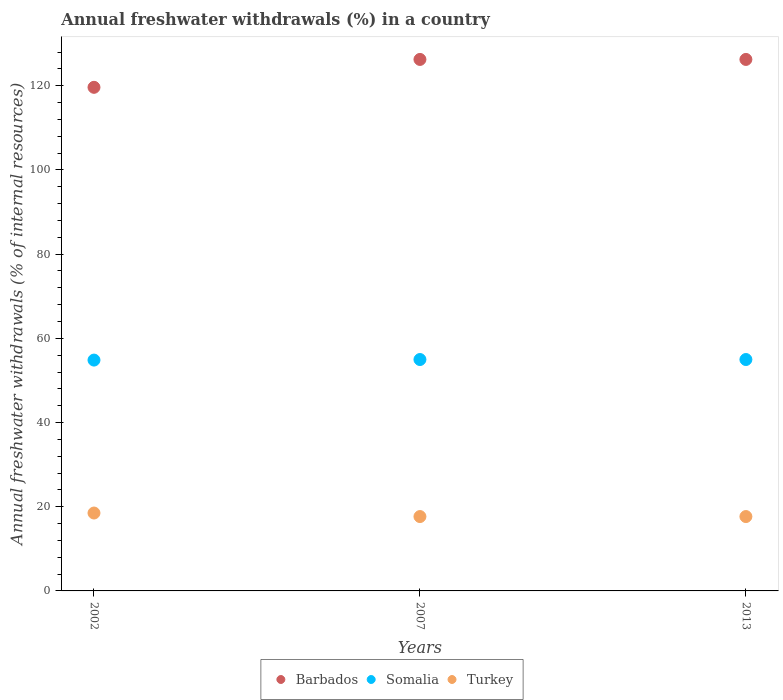How many different coloured dotlines are there?
Provide a short and direct response. 3. What is the percentage of annual freshwater withdrawals in Somalia in 2002?
Your response must be concise. 54.83. Across all years, what is the maximum percentage of annual freshwater withdrawals in Turkey?
Provide a succinct answer. 18.5. Across all years, what is the minimum percentage of annual freshwater withdrawals in Somalia?
Offer a terse response. 54.83. In which year was the percentage of annual freshwater withdrawals in Barbados maximum?
Your response must be concise. 2007. What is the total percentage of annual freshwater withdrawals in Barbados in the graph?
Provide a short and direct response. 372.12. What is the difference between the percentage of annual freshwater withdrawals in Barbados in 2002 and that in 2013?
Offer a very short reply. -6.62. What is the difference between the percentage of annual freshwater withdrawals in Barbados in 2002 and the percentage of annual freshwater withdrawals in Somalia in 2013?
Offer a terse response. 64.66. What is the average percentage of annual freshwater withdrawals in Turkey per year?
Give a very brief answer. 17.94. In the year 2007, what is the difference between the percentage of annual freshwater withdrawals in Turkey and percentage of annual freshwater withdrawals in Somalia?
Offer a very short reply. -37.3. In how many years, is the percentage of annual freshwater withdrawals in Somalia greater than 72 %?
Offer a very short reply. 0. What is the ratio of the percentage of annual freshwater withdrawals in Barbados in 2002 to that in 2007?
Make the answer very short. 0.95. Is the percentage of annual freshwater withdrawals in Barbados in 2007 less than that in 2013?
Keep it short and to the point. No. What is the difference between the highest and the second highest percentage of annual freshwater withdrawals in Somalia?
Your answer should be compact. 0. What is the difference between the highest and the lowest percentage of annual freshwater withdrawals in Barbados?
Offer a very short reply. 6.62. In how many years, is the percentage of annual freshwater withdrawals in Turkey greater than the average percentage of annual freshwater withdrawals in Turkey taken over all years?
Ensure brevity in your answer.  1. Is the sum of the percentage of annual freshwater withdrawals in Barbados in 2002 and 2013 greater than the maximum percentage of annual freshwater withdrawals in Somalia across all years?
Make the answer very short. Yes. Is it the case that in every year, the sum of the percentage of annual freshwater withdrawals in Turkey and percentage of annual freshwater withdrawals in Barbados  is greater than the percentage of annual freshwater withdrawals in Somalia?
Your response must be concise. Yes. Is the percentage of annual freshwater withdrawals in Barbados strictly greater than the percentage of annual freshwater withdrawals in Turkey over the years?
Provide a succinct answer. Yes. Is the percentage of annual freshwater withdrawals in Barbados strictly less than the percentage of annual freshwater withdrawals in Turkey over the years?
Provide a succinct answer. No. How many dotlines are there?
Make the answer very short. 3. What is the difference between two consecutive major ticks on the Y-axis?
Give a very brief answer. 20. Does the graph contain grids?
Offer a terse response. No. What is the title of the graph?
Offer a very short reply. Annual freshwater withdrawals (%) in a country. What is the label or title of the X-axis?
Provide a succinct answer. Years. What is the label or title of the Y-axis?
Ensure brevity in your answer.  Annual freshwater withdrawals (% of internal resources). What is the Annual freshwater withdrawals (% of internal resources) of Barbados in 2002?
Provide a short and direct response. 119.62. What is the Annual freshwater withdrawals (% of internal resources) in Somalia in 2002?
Provide a succinct answer. 54.83. What is the Annual freshwater withdrawals (% of internal resources) in Turkey in 2002?
Keep it short and to the point. 18.5. What is the Annual freshwater withdrawals (% of internal resources) in Barbados in 2007?
Offer a terse response. 126.25. What is the Annual freshwater withdrawals (% of internal resources) in Somalia in 2007?
Offer a very short reply. 54.97. What is the Annual freshwater withdrawals (% of internal resources) in Turkey in 2007?
Provide a short and direct response. 17.67. What is the Annual freshwater withdrawals (% of internal resources) of Barbados in 2013?
Your answer should be compact. 126.25. What is the Annual freshwater withdrawals (% of internal resources) in Somalia in 2013?
Provide a short and direct response. 54.97. What is the Annual freshwater withdrawals (% of internal resources) in Turkey in 2013?
Your answer should be compact. 17.67. Across all years, what is the maximum Annual freshwater withdrawals (% of internal resources) of Barbados?
Your response must be concise. 126.25. Across all years, what is the maximum Annual freshwater withdrawals (% of internal resources) in Somalia?
Offer a terse response. 54.97. Across all years, what is the maximum Annual freshwater withdrawals (% of internal resources) of Turkey?
Ensure brevity in your answer.  18.5. Across all years, what is the minimum Annual freshwater withdrawals (% of internal resources) in Barbados?
Offer a very short reply. 119.62. Across all years, what is the minimum Annual freshwater withdrawals (% of internal resources) in Somalia?
Ensure brevity in your answer.  54.83. Across all years, what is the minimum Annual freshwater withdrawals (% of internal resources) of Turkey?
Ensure brevity in your answer.  17.67. What is the total Annual freshwater withdrawals (% of internal resources) in Barbados in the graph?
Give a very brief answer. 372.12. What is the total Annual freshwater withdrawals (% of internal resources) of Somalia in the graph?
Make the answer very short. 164.77. What is the total Annual freshwater withdrawals (% of internal resources) in Turkey in the graph?
Offer a very short reply. 53.83. What is the difference between the Annual freshwater withdrawals (% of internal resources) in Barbados in 2002 and that in 2007?
Offer a very short reply. -6.62. What is the difference between the Annual freshwater withdrawals (% of internal resources) in Somalia in 2002 and that in 2007?
Provide a short and direct response. -0.13. What is the difference between the Annual freshwater withdrawals (% of internal resources) in Turkey in 2002 and that in 2007?
Offer a terse response. 0.84. What is the difference between the Annual freshwater withdrawals (% of internal resources) in Barbados in 2002 and that in 2013?
Ensure brevity in your answer.  -6.62. What is the difference between the Annual freshwater withdrawals (% of internal resources) in Somalia in 2002 and that in 2013?
Keep it short and to the point. -0.13. What is the difference between the Annual freshwater withdrawals (% of internal resources) of Turkey in 2002 and that in 2013?
Offer a very short reply. 0.84. What is the difference between the Annual freshwater withdrawals (% of internal resources) in Barbados in 2007 and that in 2013?
Provide a short and direct response. 0. What is the difference between the Annual freshwater withdrawals (% of internal resources) of Turkey in 2007 and that in 2013?
Your answer should be very brief. 0. What is the difference between the Annual freshwater withdrawals (% of internal resources) of Barbados in 2002 and the Annual freshwater withdrawals (% of internal resources) of Somalia in 2007?
Keep it short and to the point. 64.66. What is the difference between the Annual freshwater withdrawals (% of internal resources) in Barbados in 2002 and the Annual freshwater withdrawals (% of internal resources) in Turkey in 2007?
Make the answer very short. 101.96. What is the difference between the Annual freshwater withdrawals (% of internal resources) of Somalia in 2002 and the Annual freshwater withdrawals (% of internal resources) of Turkey in 2007?
Make the answer very short. 37.17. What is the difference between the Annual freshwater withdrawals (% of internal resources) of Barbados in 2002 and the Annual freshwater withdrawals (% of internal resources) of Somalia in 2013?
Offer a terse response. 64.66. What is the difference between the Annual freshwater withdrawals (% of internal resources) of Barbados in 2002 and the Annual freshwater withdrawals (% of internal resources) of Turkey in 2013?
Ensure brevity in your answer.  101.96. What is the difference between the Annual freshwater withdrawals (% of internal resources) of Somalia in 2002 and the Annual freshwater withdrawals (% of internal resources) of Turkey in 2013?
Offer a very short reply. 37.17. What is the difference between the Annual freshwater withdrawals (% of internal resources) of Barbados in 2007 and the Annual freshwater withdrawals (% of internal resources) of Somalia in 2013?
Offer a terse response. 71.28. What is the difference between the Annual freshwater withdrawals (% of internal resources) of Barbados in 2007 and the Annual freshwater withdrawals (% of internal resources) of Turkey in 2013?
Offer a terse response. 108.58. What is the difference between the Annual freshwater withdrawals (% of internal resources) in Somalia in 2007 and the Annual freshwater withdrawals (% of internal resources) in Turkey in 2013?
Give a very brief answer. 37.3. What is the average Annual freshwater withdrawals (% of internal resources) in Barbados per year?
Keep it short and to the point. 124.04. What is the average Annual freshwater withdrawals (% of internal resources) in Somalia per year?
Offer a very short reply. 54.92. What is the average Annual freshwater withdrawals (% of internal resources) in Turkey per year?
Your response must be concise. 17.94. In the year 2002, what is the difference between the Annual freshwater withdrawals (% of internal resources) of Barbados and Annual freshwater withdrawals (% of internal resources) of Somalia?
Make the answer very short. 64.79. In the year 2002, what is the difference between the Annual freshwater withdrawals (% of internal resources) in Barbados and Annual freshwater withdrawals (% of internal resources) in Turkey?
Your response must be concise. 101.12. In the year 2002, what is the difference between the Annual freshwater withdrawals (% of internal resources) of Somalia and Annual freshwater withdrawals (% of internal resources) of Turkey?
Keep it short and to the point. 36.33. In the year 2007, what is the difference between the Annual freshwater withdrawals (% of internal resources) of Barbados and Annual freshwater withdrawals (% of internal resources) of Somalia?
Provide a succinct answer. 71.28. In the year 2007, what is the difference between the Annual freshwater withdrawals (% of internal resources) in Barbados and Annual freshwater withdrawals (% of internal resources) in Turkey?
Provide a short and direct response. 108.58. In the year 2007, what is the difference between the Annual freshwater withdrawals (% of internal resources) of Somalia and Annual freshwater withdrawals (% of internal resources) of Turkey?
Keep it short and to the point. 37.3. In the year 2013, what is the difference between the Annual freshwater withdrawals (% of internal resources) of Barbados and Annual freshwater withdrawals (% of internal resources) of Somalia?
Your response must be concise. 71.28. In the year 2013, what is the difference between the Annual freshwater withdrawals (% of internal resources) of Barbados and Annual freshwater withdrawals (% of internal resources) of Turkey?
Your answer should be compact. 108.58. In the year 2013, what is the difference between the Annual freshwater withdrawals (% of internal resources) of Somalia and Annual freshwater withdrawals (% of internal resources) of Turkey?
Give a very brief answer. 37.3. What is the ratio of the Annual freshwater withdrawals (% of internal resources) of Barbados in 2002 to that in 2007?
Your response must be concise. 0.95. What is the ratio of the Annual freshwater withdrawals (% of internal resources) in Somalia in 2002 to that in 2007?
Provide a short and direct response. 1. What is the ratio of the Annual freshwater withdrawals (% of internal resources) of Turkey in 2002 to that in 2007?
Offer a terse response. 1.05. What is the ratio of the Annual freshwater withdrawals (% of internal resources) in Barbados in 2002 to that in 2013?
Make the answer very short. 0.95. What is the ratio of the Annual freshwater withdrawals (% of internal resources) in Turkey in 2002 to that in 2013?
Make the answer very short. 1.05. What is the ratio of the Annual freshwater withdrawals (% of internal resources) in Barbados in 2007 to that in 2013?
Your answer should be compact. 1. What is the difference between the highest and the second highest Annual freshwater withdrawals (% of internal resources) in Turkey?
Ensure brevity in your answer.  0.84. What is the difference between the highest and the lowest Annual freshwater withdrawals (% of internal resources) of Barbados?
Your answer should be very brief. 6.62. What is the difference between the highest and the lowest Annual freshwater withdrawals (% of internal resources) of Somalia?
Your response must be concise. 0.13. What is the difference between the highest and the lowest Annual freshwater withdrawals (% of internal resources) in Turkey?
Keep it short and to the point. 0.84. 